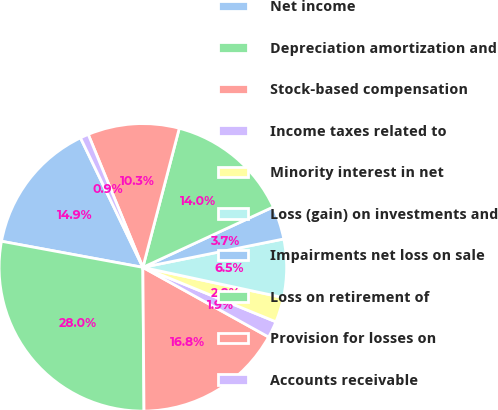Convert chart. <chart><loc_0><loc_0><loc_500><loc_500><pie_chart><fcel>Net income<fcel>Depreciation amortization and<fcel>Stock-based compensation<fcel>Income taxes related to<fcel>Minority interest in net<fcel>Loss (gain) on investments and<fcel>Impairments net loss on sale<fcel>Loss on retirement of<fcel>Provision for losses on<fcel>Accounts receivable<nl><fcel>14.95%<fcel>28.03%<fcel>16.82%<fcel>1.87%<fcel>2.81%<fcel>6.54%<fcel>3.74%<fcel>14.02%<fcel>10.28%<fcel>0.94%<nl></chart> 